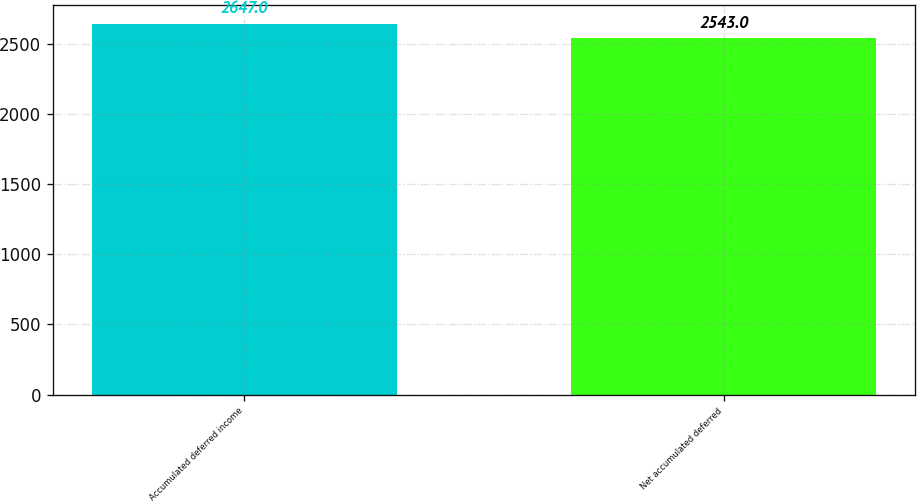Convert chart to OTSL. <chart><loc_0><loc_0><loc_500><loc_500><bar_chart><fcel>Accumulated deferred income<fcel>Net accumulated deferred<nl><fcel>2647<fcel>2543<nl></chart> 